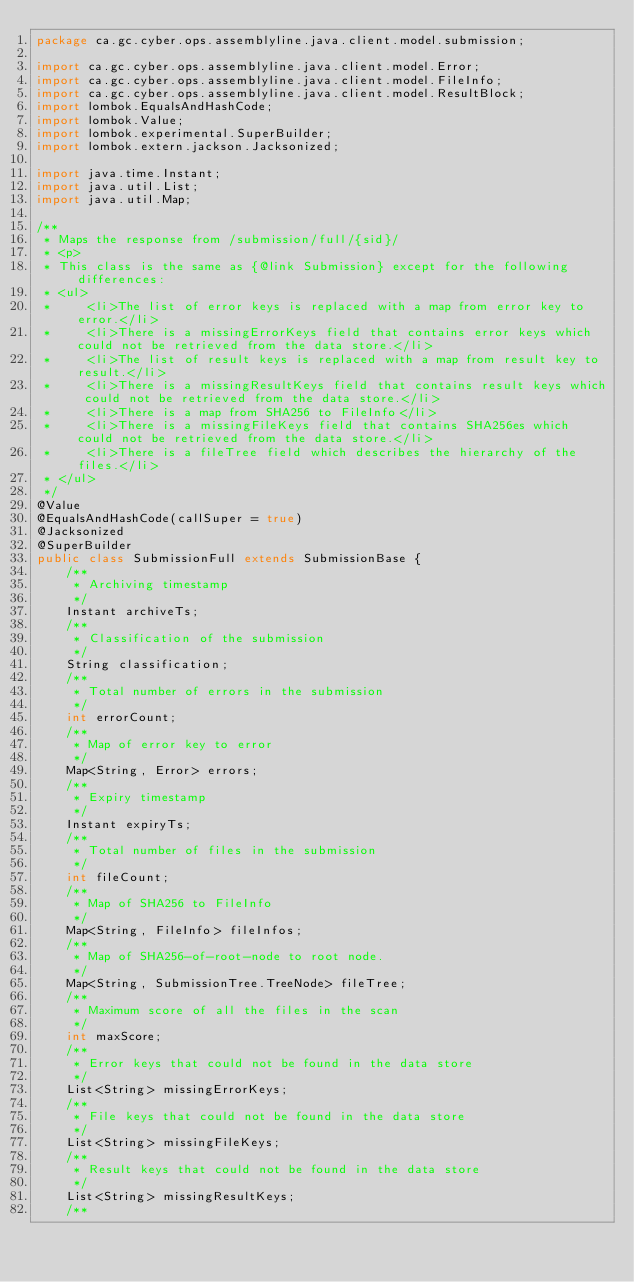Convert code to text. <code><loc_0><loc_0><loc_500><loc_500><_Java_>package ca.gc.cyber.ops.assemblyline.java.client.model.submission;

import ca.gc.cyber.ops.assemblyline.java.client.model.Error;
import ca.gc.cyber.ops.assemblyline.java.client.model.FileInfo;
import ca.gc.cyber.ops.assemblyline.java.client.model.ResultBlock;
import lombok.EqualsAndHashCode;
import lombok.Value;
import lombok.experimental.SuperBuilder;
import lombok.extern.jackson.Jacksonized;

import java.time.Instant;
import java.util.List;
import java.util.Map;

/**
 * Maps the response from /submission/full/{sid}/
 * <p>
 * This class is the same as {@link Submission} except for the following differences:
 * <ul>
 *     <li>The list of error keys is replaced with a map from error key to error.</li>
 *     <li>There is a missingErrorKeys field that contains error keys which could not be retrieved from the data store.</li>
 *     <li>The list of result keys is replaced with a map from result key to result.</li>
 *     <li>There is a missingResultKeys field that contains result keys which could not be retrieved from the data store.</li>
 *     <li>There is a map from SHA256 to FileInfo</li>
 *     <li>There is a missingFileKeys field that contains SHA256es which could not be retrieved from the data store.</li>
 *     <li>There is a fileTree field which describes the hierarchy of the files.</li>
 * </ul>
 */
@Value
@EqualsAndHashCode(callSuper = true)
@Jacksonized
@SuperBuilder
public class SubmissionFull extends SubmissionBase {
    /**
     * Archiving timestamp
     */
    Instant archiveTs;
    /**
     * Classification of the submission
     */
    String classification;
    /**
     * Total number of errors in the submission
     */
    int errorCount;
    /**
     * Map of error key to error
     */
    Map<String, Error> errors;
    /**
     * Expiry timestamp
     */
    Instant expiryTs;
    /**
     * Total number of files in the submission
     */
    int fileCount;
    /**
     * Map of SHA256 to FileInfo
     */
    Map<String, FileInfo> fileInfos;
    /**
     * Map of SHA256-of-root-node to root node.
     */
    Map<String, SubmissionTree.TreeNode> fileTree;
    /**
     * Maximum score of all the files in the scan
     */
    int maxScore;
    /**
     * Error keys that could not be found in the data store
     */
    List<String> missingErrorKeys;
    /**
     * File keys that could not be found in the data store
     */
    List<String> missingFileKeys;
    /**
     * Result keys that could not be found in the data store
     */
    List<String> missingResultKeys;
    /**</code> 